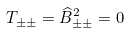<formula> <loc_0><loc_0><loc_500><loc_500>T _ { \pm \pm } = \widehat { B } _ { \pm \pm } ^ { 2 } = 0</formula> 